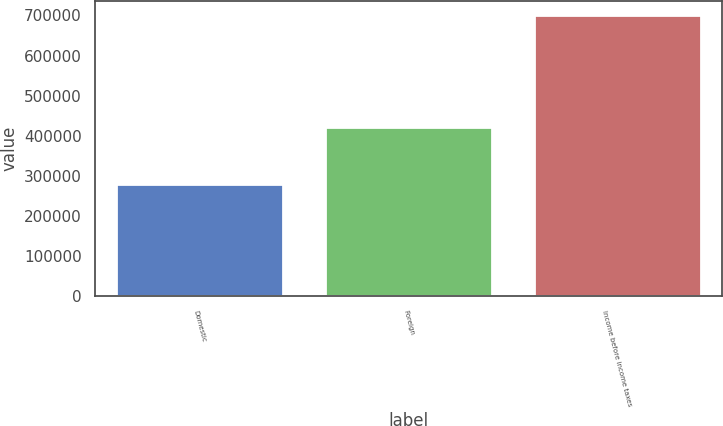Convert chart. <chart><loc_0><loc_0><loc_500><loc_500><bar_chart><fcel>Domestic<fcel>Foreign<fcel>Income before income taxes<nl><fcel>279095<fcel>422425<fcel>701520<nl></chart> 